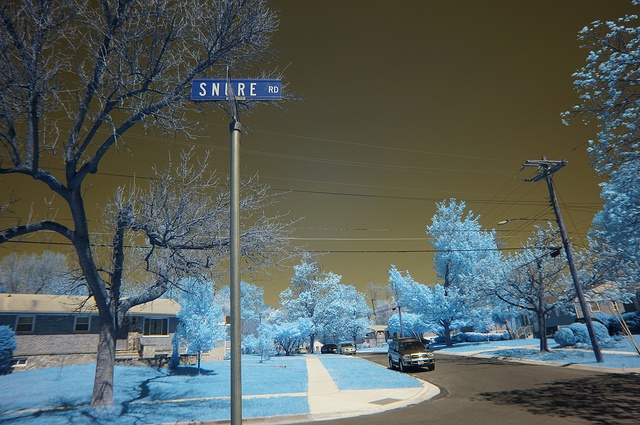Describe the objects in this image and their specific colors. I can see truck in black, gray, blue, and navy tones, car in black, gray, navy, and darkgray tones, truck in black, gray, navy, and blue tones, car in black, navy, and blue tones, and car in black, darkgray, gray, and lightblue tones in this image. 